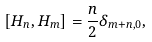<formula> <loc_0><loc_0><loc_500><loc_500>[ H _ { n } , H _ { m } ] = \frac { n } { 2 } \delta _ { m + n , 0 } ,</formula> 